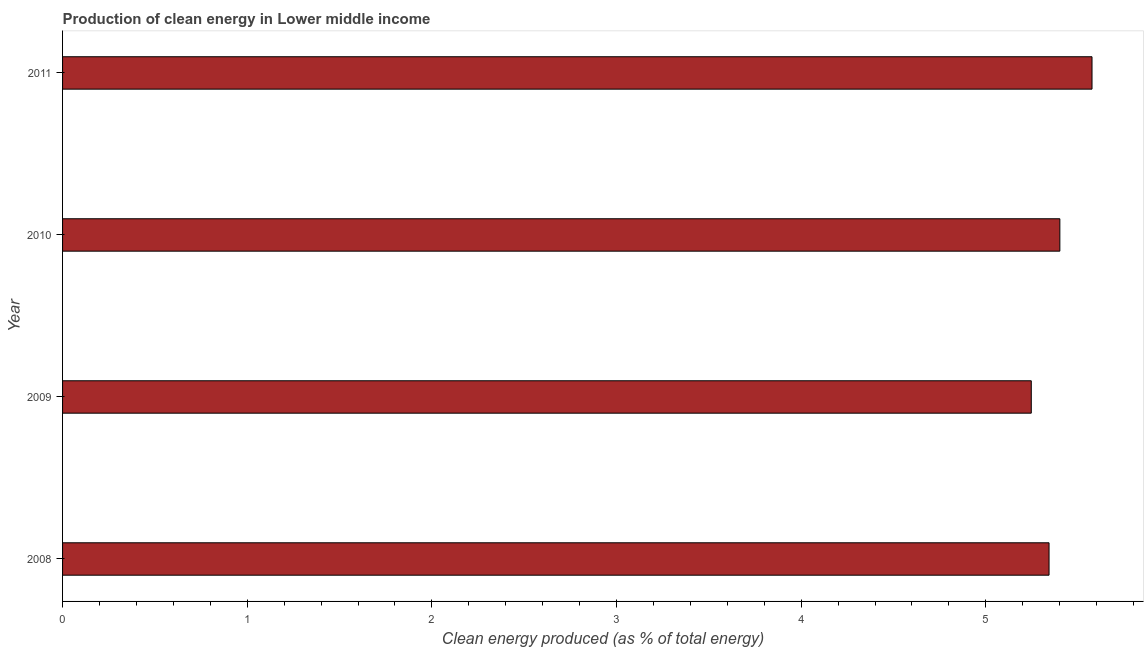What is the title of the graph?
Provide a succinct answer. Production of clean energy in Lower middle income. What is the label or title of the X-axis?
Give a very brief answer. Clean energy produced (as % of total energy). What is the label or title of the Y-axis?
Offer a very short reply. Year. What is the production of clean energy in 2010?
Your response must be concise. 5.4. Across all years, what is the maximum production of clean energy?
Offer a very short reply. 5.58. Across all years, what is the minimum production of clean energy?
Give a very brief answer. 5.25. In which year was the production of clean energy maximum?
Make the answer very short. 2011. In which year was the production of clean energy minimum?
Offer a terse response. 2009. What is the sum of the production of clean energy?
Provide a short and direct response. 21.57. What is the difference between the production of clean energy in 2009 and 2011?
Keep it short and to the point. -0.33. What is the average production of clean energy per year?
Your answer should be very brief. 5.39. What is the median production of clean energy?
Provide a short and direct response. 5.37. In how many years, is the production of clean energy greater than 2 %?
Your response must be concise. 4. Do a majority of the years between 2009 and 2011 (inclusive) have production of clean energy greater than 3.2 %?
Keep it short and to the point. Yes. Is the production of clean energy in 2010 less than that in 2011?
Provide a succinct answer. Yes. Is the difference between the production of clean energy in 2009 and 2010 greater than the difference between any two years?
Give a very brief answer. No. What is the difference between the highest and the second highest production of clean energy?
Your response must be concise. 0.17. Is the sum of the production of clean energy in 2009 and 2011 greater than the maximum production of clean energy across all years?
Ensure brevity in your answer.  Yes. What is the difference between the highest and the lowest production of clean energy?
Provide a succinct answer. 0.33. In how many years, is the production of clean energy greater than the average production of clean energy taken over all years?
Give a very brief answer. 2. How many bars are there?
Offer a terse response. 4. Are the values on the major ticks of X-axis written in scientific E-notation?
Provide a succinct answer. No. What is the Clean energy produced (as % of total energy) of 2008?
Make the answer very short. 5.34. What is the Clean energy produced (as % of total energy) in 2009?
Provide a succinct answer. 5.25. What is the Clean energy produced (as % of total energy) in 2010?
Give a very brief answer. 5.4. What is the Clean energy produced (as % of total energy) in 2011?
Your answer should be compact. 5.58. What is the difference between the Clean energy produced (as % of total energy) in 2008 and 2009?
Make the answer very short. 0.1. What is the difference between the Clean energy produced (as % of total energy) in 2008 and 2010?
Your response must be concise. -0.06. What is the difference between the Clean energy produced (as % of total energy) in 2008 and 2011?
Your response must be concise. -0.23. What is the difference between the Clean energy produced (as % of total energy) in 2009 and 2010?
Ensure brevity in your answer.  -0.15. What is the difference between the Clean energy produced (as % of total energy) in 2009 and 2011?
Keep it short and to the point. -0.33. What is the difference between the Clean energy produced (as % of total energy) in 2010 and 2011?
Your answer should be compact. -0.17. What is the ratio of the Clean energy produced (as % of total energy) in 2008 to that in 2009?
Make the answer very short. 1.02. What is the ratio of the Clean energy produced (as % of total energy) in 2008 to that in 2011?
Your answer should be very brief. 0.96. What is the ratio of the Clean energy produced (as % of total energy) in 2009 to that in 2011?
Provide a succinct answer. 0.94. What is the ratio of the Clean energy produced (as % of total energy) in 2010 to that in 2011?
Offer a very short reply. 0.97. 